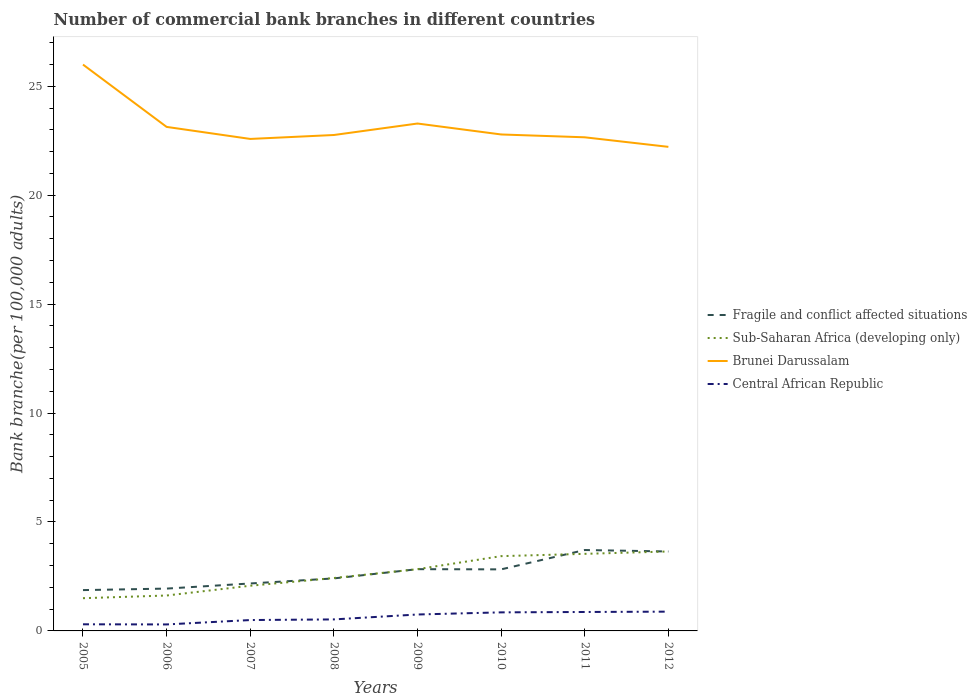How many different coloured lines are there?
Keep it short and to the point. 4. Across all years, what is the maximum number of commercial bank branches in Fragile and conflict affected situations?
Provide a succinct answer. 1.87. In which year was the number of commercial bank branches in Fragile and conflict affected situations maximum?
Provide a succinct answer. 2005. What is the total number of commercial bank branches in Brunei Darussalam in the graph?
Make the answer very short. 0.55. What is the difference between the highest and the second highest number of commercial bank branches in Sub-Saharan Africa (developing only)?
Offer a terse response. 2.14. What is the difference between the highest and the lowest number of commercial bank branches in Sub-Saharan Africa (developing only)?
Make the answer very short. 4. Is the number of commercial bank branches in Fragile and conflict affected situations strictly greater than the number of commercial bank branches in Brunei Darussalam over the years?
Ensure brevity in your answer.  Yes. How many lines are there?
Offer a very short reply. 4. What is the difference between two consecutive major ticks on the Y-axis?
Make the answer very short. 5. Does the graph contain grids?
Your answer should be very brief. No. How many legend labels are there?
Keep it short and to the point. 4. What is the title of the graph?
Keep it short and to the point. Number of commercial bank branches in different countries. Does "India" appear as one of the legend labels in the graph?
Your answer should be compact. No. What is the label or title of the X-axis?
Offer a very short reply. Years. What is the label or title of the Y-axis?
Keep it short and to the point. Bank branche(per 100,0 adults). What is the Bank branche(per 100,000 adults) of Fragile and conflict affected situations in 2005?
Your answer should be very brief. 1.87. What is the Bank branche(per 100,000 adults) in Sub-Saharan Africa (developing only) in 2005?
Make the answer very short. 1.5. What is the Bank branche(per 100,000 adults) of Brunei Darussalam in 2005?
Your response must be concise. 25.99. What is the Bank branche(per 100,000 adults) of Central African Republic in 2005?
Your response must be concise. 0.3. What is the Bank branche(per 100,000 adults) in Fragile and conflict affected situations in 2006?
Offer a terse response. 1.94. What is the Bank branche(per 100,000 adults) of Sub-Saharan Africa (developing only) in 2006?
Give a very brief answer. 1.63. What is the Bank branche(per 100,000 adults) of Brunei Darussalam in 2006?
Offer a very short reply. 23.13. What is the Bank branche(per 100,000 adults) in Central African Republic in 2006?
Provide a short and direct response. 0.3. What is the Bank branche(per 100,000 adults) of Fragile and conflict affected situations in 2007?
Ensure brevity in your answer.  2.18. What is the Bank branche(per 100,000 adults) in Sub-Saharan Africa (developing only) in 2007?
Your answer should be very brief. 2.07. What is the Bank branche(per 100,000 adults) in Brunei Darussalam in 2007?
Your response must be concise. 22.58. What is the Bank branche(per 100,000 adults) in Central African Republic in 2007?
Make the answer very short. 0.5. What is the Bank branche(per 100,000 adults) in Fragile and conflict affected situations in 2008?
Provide a short and direct response. 2.41. What is the Bank branche(per 100,000 adults) in Sub-Saharan Africa (developing only) in 2008?
Keep it short and to the point. 2.43. What is the Bank branche(per 100,000 adults) of Brunei Darussalam in 2008?
Provide a short and direct response. 22.76. What is the Bank branche(per 100,000 adults) in Central African Republic in 2008?
Your answer should be very brief. 0.53. What is the Bank branche(per 100,000 adults) of Fragile and conflict affected situations in 2009?
Your answer should be very brief. 2.83. What is the Bank branche(per 100,000 adults) of Sub-Saharan Africa (developing only) in 2009?
Provide a succinct answer. 2.83. What is the Bank branche(per 100,000 adults) in Brunei Darussalam in 2009?
Make the answer very short. 23.29. What is the Bank branche(per 100,000 adults) in Central African Republic in 2009?
Give a very brief answer. 0.75. What is the Bank branche(per 100,000 adults) in Fragile and conflict affected situations in 2010?
Make the answer very short. 2.83. What is the Bank branche(per 100,000 adults) of Sub-Saharan Africa (developing only) in 2010?
Keep it short and to the point. 3.43. What is the Bank branche(per 100,000 adults) of Brunei Darussalam in 2010?
Offer a terse response. 22.79. What is the Bank branche(per 100,000 adults) of Central African Republic in 2010?
Ensure brevity in your answer.  0.85. What is the Bank branche(per 100,000 adults) in Fragile and conflict affected situations in 2011?
Ensure brevity in your answer.  3.71. What is the Bank branche(per 100,000 adults) in Sub-Saharan Africa (developing only) in 2011?
Offer a terse response. 3.54. What is the Bank branche(per 100,000 adults) of Brunei Darussalam in 2011?
Offer a very short reply. 22.66. What is the Bank branche(per 100,000 adults) of Central African Republic in 2011?
Offer a terse response. 0.87. What is the Bank branche(per 100,000 adults) of Fragile and conflict affected situations in 2012?
Provide a short and direct response. 3.65. What is the Bank branche(per 100,000 adults) in Sub-Saharan Africa (developing only) in 2012?
Your response must be concise. 3.65. What is the Bank branche(per 100,000 adults) in Brunei Darussalam in 2012?
Ensure brevity in your answer.  22.22. What is the Bank branche(per 100,000 adults) of Central African Republic in 2012?
Your answer should be very brief. 0.88. Across all years, what is the maximum Bank branche(per 100,000 adults) of Fragile and conflict affected situations?
Offer a terse response. 3.71. Across all years, what is the maximum Bank branche(per 100,000 adults) of Sub-Saharan Africa (developing only)?
Ensure brevity in your answer.  3.65. Across all years, what is the maximum Bank branche(per 100,000 adults) of Brunei Darussalam?
Make the answer very short. 25.99. Across all years, what is the maximum Bank branche(per 100,000 adults) in Central African Republic?
Provide a short and direct response. 0.88. Across all years, what is the minimum Bank branche(per 100,000 adults) of Fragile and conflict affected situations?
Offer a very short reply. 1.87. Across all years, what is the minimum Bank branche(per 100,000 adults) in Sub-Saharan Africa (developing only)?
Your answer should be very brief. 1.5. Across all years, what is the minimum Bank branche(per 100,000 adults) in Brunei Darussalam?
Your answer should be compact. 22.22. Across all years, what is the minimum Bank branche(per 100,000 adults) in Central African Republic?
Your answer should be compact. 0.3. What is the total Bank branche(per 100,000 adults) in Fragile and conflict affected situations in the graph?
Ensure brevity in your answer.  21.42. What is the total Bank branche(per 100,000 adults) of Sub-Saharan Africa (developing only) in the graph?
Your answer should be very brief. 21.08. What is the total Bank branche(per 100,000 adults) of Brunei Darussalam in the graph?
Make the answer very short. 185.42. What is the total Bank branche(per 100,000 adults) of Central African Republic in the graph?
Your response must be concise. 4.99. What is the difference between the Bank branche(per 100,000 adults) of Fragile and conflict affected situations in 2005 and that in 2006?
Offer a very short reply. -0.07. What is the difference between the Bank branche(per 100,000 adults) of Sub-Saharan Africa (developing only) in 2005 and that in 2006?
Provide a succinct answer. -0.12. What is the difference between the Bank branche(per 100,000 adults) of Brunei Darussalam in 2005 and that in 2006?
Your answer should be very brief. 2.86. What is the difference between the Bank branche(per 100,000 adults) in Central African Republic in 2005 and that in 2006?
Provide a short and direct response. 0.01. What is the difference between the Bank branche(per 100,000 adults) in Fragile and conflict affected situations in 2005 and that in 2007?
Provide a succinct answer. -0.3. What is the difference between the Bank branche(per 100,000 adults) in Sub-Saharan Africa (developing only) in 2005 and that in 2007?
Ensure brevity in your answer.  -0.57. What is the difference between the Bank branche(per 100,000 adults) in Brunei Darussalam in 2005 and that in 2007?
Offer a very short reply. 3.41. What is the difference between the Bank branche(per 100,000 adults) of Central African Republic in 2005 and that in 2007?
Offer a terse response. -0.2. What is the difference between the Bank branche(per 100,000 adults) of Fragile and conflict affected situations in 2005 and that in 2008?
Provide a short and direct response. -0.54. What is the difference between the Bank branche(per 100,000 adults) of Sub-Saharan Africa (developing only) in 2005 and that in 2008?
Offer a terse response. -0.93. What is the difference between the Bank branche(per 100,000 adults) of Brunei Darussalam in 2005 and that in 2008?
Give a very brief answer. 3.23. What is the difference between the Bank branche(per 100,000 adults) of Central African Republic in 2005 and that in 2008?
Provide a succinct answer. -0.22. What is the difference between the Bank branche(per 100,000 adults) of Fragile and conflict affected situations in 2005 and that in 2009?
Make the answer very short. -0.96. What is the difference between the Bank branche(per 100,000 adults) of Sub-Saharan Africa (developing only) in 2005 and that in 2009?
Your answer should be very brief. -1.33. What is the difference between the Bank branche(per 100,000 adults) in Brunei Darussalam in 2005 and that in 2009?
Provide a short and direct response. 2.71. What is the difference between the Bank branche(per 100,000 adults) in Central African Republic in 2005 and that in 2009?
Make the answer very short. -0.45. What is the difference between the Bank branche(per 100,000 adults) of Fragile and conflict affected situations in 2005 and that in 2010?
Ensure brevity in your answer.  -0.95. What is the difference between the Bank branche(per 100,000 adults) in Sub-Saharan Africa (developing only) in 2005 and that in 2010?
Give a very brief answer. -1.93. What is the difference between the Bank branche(per 100,000 adults) of Brunei Darussalam in 2005 and that in 2010?
Make the answer very short. 3.21. What is the difference between the Bank branche(per 100,000 adults) of Central African Republic in 2005 and that in 2010?
Keep it short and to the point. -0.55. What is the difference between the Bank branche(per 100,000 adults) of Fragile and conflict affected situations in 2005 and that in 2011?
Your answer should be compact. -1.84. What is the difference between the Bank branche(per 100,000 adults) of Sub-Saharan Africa (developing only) in 2005 and that in 2011?
Make the answer very short. -2.04. What is the difference between the Bank branche(per 100,000 adults) in Brunei Darussalam in 2005 and that in 2011?
Give a very brief answer. 3.34. What is the difference between the Bank branche(per 100,000 adults) of Central African Republic in 2005 and that in 2011?
Offer a terse response. -0.57. What is the difference between the Bank branche(per 100,000 adults) in Fragile and conflict affected situations in 2005 and that in 2012?
Your response must be concise. -1.77. What is the difference between the Bank branche(per 100,000 adults) in Sub-Saharan Africa (developing only) in 2005 and that in 2012?
Keep it short and to the point. -2.14. What is the difference between the Bank branche(per 100,000 adults) in Brunei Darussalam in 2005 and that in 2012?
Ensure brevity in your answer.  3.78. What is the difference between the Bank branche(per 100,000 adults) of Central African Republic in 2005 and that in 2012?
Your response must be concise. -0.58. What is the difference between the Bank branche(per 100,000 adults) in Fragile and conflict affected situations in 2006 and that in 2007?
Provide a short and direct response. -0.23. What is the difference between the Bank branche(per 100,000 adults) in Sub-Saharan Africa (developing only) in 2006 and that in 2007?
Offer a very short reply. -0.45. What is the difference between the Bank branche(per 100,000 adults) in Brunei Darussalam in 2006 and that in 2007?
Keep it short and to the point. 0.55. What is the difference between the Bank branche(per 100,000 adults) in Central African Republic in 2006 and that in 2007?
Offer a very short reply. -0.2. What is the difference between the Bank branche(per 100,000 adults) in Fragile and conflict affected situations in 2006 and that in 2008?
Provide a succinct answer. -0.47. What is the difference between the Bank branche(per 100,000 adults) in Sub-Saharan Africa (developing only) in 2006 and that in 2008?
Keep it short and to the point. -0.8. What is the difference between the Bank branche(per 100,000 adults) of Brunei Darussalam in 2006 and that in 2008?
Ensure brevity in your answer.  0.37. What is the difference between the Bank branche(per 100,000 adults) of Central African Republic in 2006 and that in 2008?
Offer a terse response. -0.23. What is the difference between the Bank branche(per 100,000 adults) in Fragile and conflict affected situations in 2006 and that in 2009?
Provide a succinct answer. -0.89. What is the difference between the Bank branche(per 100,000 adults) of Sub-Saharan Africa (developing only) in 2006 and that in 2009?
Keep it short and to the point. -1.21. What is the difference between the Bank branche(per 100,000 adults) of Brunei Darussalam in 2006 and that in 2009?
Provide a succinct answer. -0.15. What is the difference between the Bank branche(per 100,000 adults) in Central African Republic in 2006 and that in 2009?
Give a very brief answer. -0.46. What is the difference between the Bank branche(per 100,000 adults) in Fragile and conflict affected situations in 2006 and that in 2010?
Ensure brevity in your answer.  -0.88. What is the difference between the Bank branche(per 100,000 adults) in Sub-Saharan Africa (developing only) in 2006 and that in 2010?
Make the answer very short. -1.81. What is the difference between the Bank branche(per 100,000 adults) in Brunei Darussalam in 2006 and that in 2010?
Provide a succinct answer. 0.35. What is the difference between the Bank branche(per 100,000 adults) of Central African Republic in 2006 and that in 2010?
Your answer should be very brief. -0.55. What is the difference between the Bank branche(per 100,000 adults) of Fragile and conflict affected situations in 2006 and that in 2011?
Provide a short and direct response. -1.77. What is the difference between the Bank branche(per 100,000 adults) in Sub-Saharan Africa (developing only) in 2006 and that in 2011?
Give a very brief answer. -1.91. What is the difference between the Bank branche(per 100,000 adults) of Brunei Darussalam in 2006 and that in 2011?
Provide a succinct answer. 0.48. What is the difference between the Bank branche(per 100,000 adults) of Central African Republic in 2006 and that in 2011?
Ensure brevity in your answer.  -0.57. What is the difference between the Bank branche(per 100,000 adults) of Fragile and conflict affected situations in 2006 and that in 2012?
Provide a succinct answer. -1.7. What is the difference between the Bank branche(per 100,000 adults) of Sub-Saharan Africa (developing only) in 2006 and that in 2012?
Your answer should be very brief. -2.02. What is the difference between the Bank branche(per 100,000 adults) of Brunei Darussalam in 2006 and that in 2012?
Your response must be concise. 0.92. What is the difference between the Bank branche(per 100,000 adults) of Central African Republic in 2006 and that in 2012?
Give a very brief answer. -0.59. What is the difference between the Bank branche(per 100,000 adults) of Fragile and conflict affected situations in 2007 and that in 2008?
Keep it short and to the point. -0.23. What is the difference between the Bank branche(per 100,000 adults) of Sub-Saharan Africa (developing only) in 2007 and that in 2008?
Offer a very short reply. -0.35. What is the difference between the Bank branche(per 100,000 adults) of Brunei Darussalam in 2007 and that in 2008?
Your answer should be compact. -0.18. What is the difference between the Bank branche(per 100,000 adults) of Central African Republic in 2007 and that in 2008?
Keep it short and to the point. -0.03. What is the difference between the Bank branche(per 100,000 adults) in Fragile and conflict affected situations in 2007 and that in 2009?
Provide a short and direct response. -0.66. What is the difference between the Bank branche(per 100,000 adults) in Sub-Saharan Africa (developing only) in 2007 and that in 2009?
Provide a short and direct response. -0.76. What is the difference between the Bank branche(per 100,000 adults) in Brunei Darussalam in 2007 and that in 2009?
Give a very brief answer. -0.71. What is the difference between the Bank branche(per 100,000 adults) of Central African Republic in 2007 and that in 2009?
Offer a very short reply. -0.25. What is the difference between the Bank branche(per 100,000 adults) of Fragile and conflict affected situations in 2007 and that in 2010?
Provide a short and direct response. -0.65. What is the difference between the Bank branche(per 100,000 adults) in Sub-Saharan Africa (developing only) in 2007 and that in 2010?
Your answer should be compact. -1.36. What is the difference between the Bank branche(per 100,000 adults) of Brunei Darussalam in 2007 and that in 2010?
Give a very brief answer. -0.2. What is the difference between the Bank branche(per 100,000 adults) in Central African Republic in 2007 and that in 2010?
Your answer should be compact. -0.35. What is the difference between the Bank branche(per 100,000 adults) in Fragile and conflict affected situations in 2007 and that in 2011?
Offer a very short reply. -1.54. What is the difference between the Bank branche(per 100,000 adults) in Sub-Saharan Africa (developing only) in 2007 and that in 2011?
Give a very brief answer. -1.46. What is the difference between the Bank branche(per 100,000 adults) in Brunei Darussalam in 2007 and that in 2011?
Provide a succinct answer. -0.07. What is the difference between the Bank branche(per 100,000 adults) in Central African Republic in 2007 and that in 2011?
Keep it short and to the point. -0.37. What is the difference between the Bank branche(per 100,000 adults) in Fragile and conflict affected situations in 2007 and that in 2012?
Make the answer very short. -1.47. What is the difference between the Bank branche(per 100,000 adults) of Sub-Saharan Africa (developing only) in 2007 and that in 2012?
Your answer should be compact. -1.57. What is the difference between the Bank branche(per 100,000 adults) of Brunei Darussalam in 2007 and that in 2012?
Your answer should be very brief. 0.36. What is the difference between the Bank branche(per 100,000 adults) in Central African Republic in 2007 and that in 2012?
Ensure brevity in your answer.  -0.39. What is the difference between the Bank branche(per 100,000 adults) in Fragile and conflict affected situations in 2008 and that in 2009?
Give a very brief answer. -0.42. What is the difference between the Bank branche(per 100,000 adults) of Sub-Saharan Africa (developing only) in 2008 and that in 2009?
Offer a terse response. -0.41. What is the difference between the Bank branche(per 100,000 adults) in Brunei Darussalam in 2008 and that in 2009?
Offer a terse response. -0.53. What is the difference between the Bank branche(per 100,000 adults) in Central African Republic in 2008 and that in 2009?
Make the answer very short. -0.23. What is the difference between the Bank branche(per 100,000 adults) of Fragile and conflict affected situations in 2008 and that in 2010?
Provide a short and direct response. -0.41. What is the difference between the Bank branche(per 100,000 adults) of Sub-Saharan Africa (developing only) in 2008 and that in 2010?
Ensure brevity in your answer.  -1. What is the difference between the Bank branche(per 100,000 adults) in Brunei Darussalam in 2008 and that in 2010?
Ensure brevity in your answer.  -0.02. What is the difference between the Bank branche(per 100,000 adults) of Central African Republic in 2008 and that in 2010?
Your answer should be compact. -0.32. What is the difference between the Bank branche(per 100,000 adults) in Fragile and conflict affected situations in 2008 and that in 2011?
Offer a terse response. -1.3. What is the difference between the Bank branche(per 100,000 adults) of Sub-Saharan Africa (developing only) in 2008 and that in 2011?
Keep it short and to the point. -1.11. What is the difference between the Bank branche(per 100,000 adults) in Brunei Darussalam in 2008 and that in 2011?
Give a very brief answer. 0.11. What is the difference between the Bank branche(per 100,000 adults) of Central African Republic in 2008 and that in 2011?
Offer a very short reply. -0.34. What is the difference between the Bank branche(per 100,000 adults) of Fragile and conflict affected situations in 2008 and that in 2012?
Provide a short and direct response. -1.24. What is the difference between the Bank branche(per 100,000 adults) of Sub-Saharan Africa (developing only) in 2008 and that in 2012?
Your answer should be compact. -1.22. What is the difference between the Bank branche(per 100,000 adults) of Brunei Darussalam in 2008 and that in 2012?
Keep it short and to the point. 0.54. What is the difference between the Bank branche(per 100,000 adults) in Central African Republic in 2008 and that in 2012?
Your answer should be compact. -0.36. What is the difference between the Bank branche(per 100,000 adults) in Fragile and conflict affected situations in 2009 and that in 2010?
Your response must be concise. 0.01. What is the difference between the Bank branche(per 100,000 adults) of Sub-Saharan Africa (developing only) in 2009 and that in 2010?
Offer a very short reply. -0.6. What is the difference between the Bank branche(per 100,000 adults) in Brunei Darussalam in 2009 and that in 2010?
Make the answer very short. 0.5. What is the difference between the Bank branche(per 100,000 adults) of Central African Republic in 2009 and that in 2010?
Make the answer very short. -0.1. What is the difference between the Bank branche(per 100,000 adults) of Fragile and conflict affected situations in 2009 and that in 2011?
Your response must be concise. -0.88. What is the difference between the Bank branche(per 100,000 adults) in Sub-Saharan Africa (developing only) in 2009 and that in 2011?
Your response must be concise. -0.7. What is the difference between the Bank branche(per 100,000 adults) in Brunei Darussalam in 2009 and that in 2011?
Your response must be concise. 0.63. What is the difference between the Bank branche(per 100,000 adults) in Central African Republic in 2009 and that in 2011?
Provide a succinct answer. -0.12. What is the difference between the Bank branche(per 100,000 adults) of Fragile and conflict affected situations in 2009 and that in 2012?
Make the answer very short. -0.81. What is the difference between the Bank branche(per 100,000 adults) in Sub-Saharan Africa (developing only) in 2009 and that in 2012?
Your response must be concise. -0.81. What is the difference between the Bank branche(per 100,000 adults) in Brunei Darussalam in 2009 and that in 2012?
Give a very brief answer. 1.07. What is the difference between the Bank branche(per 100,000 adults) in Central African Republic in 2009 and that in 2012?
Your answer should be very brief. -0.13. What is the difference between the Bank branche(per 100,000 adults) in Fragile and conflict affected situations in 2010 and that in 2011?
Give a very brief answer. -0.89. What is the difference between the Bank branche(per 100,000 adults) of Sub-Saharan Africa (developing only) in 2010 and that in 2011?
Provide a short and direct response. -0.11. What is the difference between the Bank branche(per 100,000 adults) of Brunei Darussalam in 2010 and that in 2011?
Your answer should be compact. 0.13. What is the difference between the Bank branche(per 100,000 adults) in Central African Republic in 2010 and that in 2011?
Offer a terse response. -0.02. What is the difference between the Bank branche(per 100,000 adults) in Fragile and conflict affected situations in 2010 and that in 2012?
Offer a very short reply. -0.82. What is the difference between the Bank branche(per 100,000 adults) in Sub-Saharan Africa (developing only) in 2010 and that in 2012?
Keep it short and to the point. -0.21. What is the difference between the Bank branche(per 100,000 adults) in Brunei Darussalam in 2010 and that in 2012?
Your response must be concise. 0.57. What is the difference between the Bank branche(per 100,000 adults) of Central African Republic in 2010 and that in 2012?
Ensure brevity in your answer.  -0.03. What is the difference between the Bank branche(per 100,000 adults) in Fragile and conflict affected situations in 2011 and that in 2012?
Offer a very short reply. 0.07. What is the difference between the Bank branche(per 100,000 adults) in Sub-Saharan Africa (developing only) in 2011 and that in 2012?
Keep it short and to the point. -0.11. What is the difference between the Bank branche(per 100,000 adults) in Brunei Darussalam in 2011 and that in 2012?
Provide a short and direct response. 0.44. What is the difference between the Bank branche(per 100,000 adults) in Central African Republic in 2011 and that in 2012?
Provide a succinct answer. -0.02. What is the difference between the Bank branche(per 100,000 adults) in Fragile and conflict affected situations in 2005 and the Bank branche(per 100,000 adults) in Sub-Saharan Africa (developing only) in 2006?
Offer a terse response. 0.25. What is the difference between the Bank branche(per 100,000 adults) of Fragile and conflict affected situations in 2005 and the Bank branche(per 100,000 adults) of Brunei Darussalam in 2006?
Offer a very short reply. -21.26. What is the difference between the Bank branche(per 100,000 adults) of Fragile and conflict affected situations in 2005 and the Bank branche(per 100,000 adults) of Central African Republic in 2006?
Offer a very short reply. 1.58. What is the difference between the Bank branche(per 100,000 adults) of Sub-Saharan Africa (developing only) in 2005 and the Bank branche(per 100,000 adults) of Brunei Darussalam in 2006?
Ensure brevity in your answer.  -21.63. What is the difference between the Bank branche(per 100,000 adults) in Sub-Saharan Africa (developing only) in 2005 and the Bank branche(per 100,000 adults) in Central African Republic in 2006?
Keep it short and to the point. 1.2. What is the difference between the Bank branche(per 100,000 adults) in Brunei Darussalam in 2005 and the Bank branche(per 100,000 adults) in Central African Republic in 2006?
Your answer should be compact. 25.7. What is the difference between the Bank branche(per 100,000 adults) of Fragile and conflict affected situations in 2005 and the Bank branche(per 100,000 adults) of Sub-Saharan Africa (developing only) in 2007?
Provide a succinct answer. -0.2. What is the difference between the Bank branche(per 100,000 adults) in Fragile and conflict affected situations in 2005 and the Bank branche(per 100,000 adults) in Brunei Darussalam in 2007?
Give a very brief answer. -20.71. What is the difference between the Bank branche(per 100,000 adults) in Fragile and conflict affected situations in 2005 and the Bank branche(per 100,000 adults) in Central African Republic in 2007?
Make the answer very short. 1.37. What is the difference between the Bank branche(per 100,000 adults) of Sub-Saharan Africa (developing only) in 2005 and the Bank branche(per 100,000 adults) of Brunei Darussalam in 2007?
Provide a succinct answer. -21.08. What is the difference between the Bank branche(per 100,000 adults) in Sub-Saharan Africa (developing only) in 2005 and the Bank branche(per 100,000 adults) in Central African Republic in 2007?
Your response must be concise. 1. What is the difference between the Bank branche(per 100,000 adults) in Brunei Darussalam in 2005 and the Bank branche(per 100,000 adults) in Central African Republic in 2007?
Offer a terse response. 25.49. What is the difference between the Bank branche(per 100,000 adults) in Fragile and conflict affected situations in 2005 and the Bank branche(per 100,000 adults) in Sub-Saharan Africa (developing only) in 2008?
Your answer should be compact. -0.55. What is the difference between the Bank branche(per 100,000 adults) in Fragile and conflict affected situations in 2005 and the Bank branche(per 100,000 adults) in Brunei Darussalam in 2008?
Give a very brief answer. -20.89. What is the difference between the Bank branche(per 100,000 adults) of Fragile and conflict affected situations in 2005 and the Bank branche(per 100,000 adults) of Central African Republic in 2008?
Offer a very short reply. 1.35. What is the difference between the Bank branche(per 100,000 adults) of Sub-Saharan Africa (developing only) in 2005 and the Bank branche(per 100,000 adults) of Brunei Darussalam in 2008?
Offer a very short reply. -21.26. What is the difference between the Bank branche(per 100,000 adults) in Sub-Saharan Africa (developing only) in 2005 and the Bank branche(per 100,000 adults) in Central African Republic in 2008?
Your answer should be very brief. 0.97. What is the difference between the Bank branche(per 100,000 adults) of Brunei Darussalam in 2005 and the Bank branche(per 100,000 adults) of Central African Republic in 2008?
Ensure brevity in your answer.  25.47. What is the difference between the Bank branche(per 100,000 adults) of Fragile and conflict affected situations in 2005 and the Bank branche(per 100,000 adults) of Sub-Saharan Africa (developing only) in 2009?
Your answer should be very brief. -0.96. What is the difference between the Bank branche(per 100,000 adults) of Fragile and conflict affected situations in 2005 and the Bank branche(per 100,000 adults) of Brunei Darussalam in 2009?
Make the answer very short. -21.41. What is the difference between the Bank branche(per 100,000 adults) of Fragile and conflict affected situations in 2005 and the Bank branche(per 100,000 adults) of Central African Republic in 2009?
Provide a short and direct response. 1.12. What is the difference between the Bank branche(per 100,000 adults) in Sub-Saharan Africa (developing only) in 2005 and the Bank branche(per 100,000 adults) in Brunei Darussalam in 2009?
Make the answer very short. -21.79. What is the difference between the Bank branche(per 100,000 adults) of Sub-Saharan Africa (developing only) in 2005 and the Bank branche(per 100,000 adults) of Central African Republic in 2009?
Offer a very short reply. 0.75. What is the difference between the Bank branche(per 100,000 adults) in Brunei Darussalam in 2005 and the Bank branche(per 100,000 adults) in Central African Republic in 2009?
Provide a short and direct response. 25.24. What is the difference between the Bank branche(per 100,000 adults) in Fragile and conflict affected situations in 2005 and the Bank branche(per 100,000 adults) in Sub-Saharan Africa (developing only) in 2010?
Give a very brief answer. -1.56. What is the difference between the Bank branche(per 100,000 adults) of Fragile and conflict affected situations in 2005 and the Bank branche(per 100,000 adults) of Brunei Darussalam in 2010?
Offer a terse response. -20.91. What is the difference between the Bank branche(per 100,000 adults) in Fragile and conflict affected situations in 2005 and the Bank branche(per 100,000 adults) in Central African Republic in 2010?
Provide a succinct answer. 1.02. What is the difference between the Bank branche(per 100,000 adults) in Sub-Saharan Africa (developing only) in 2005 and the Bank branche(per 100,000 adults) in Brunei Darussalam in 2010?
Provide a succinct answer. -21.28. What is the difference between the Bank branche(per 100,000 adults) of Sub-Saharan Africa (developing only) in 2005 and the Bank branche(per 100,000 adults) of Central African Republic in 2010?
Give a very brief answer. 0.65. What is the difference between the Bank branche(per 100,000 adults) in Brunei Darussalam in 2005 and the Bank branche(per 100,000 adults) in Central African Republic in 2010?
Provide a succinct answer. 25.14. What is the difference between the Bank branche(per 100,000 adults) of Fragile and conflict affected situations in 2005 and the Bank branche(per 100,000 adults) of Sub-Saharan Africa (developing only) in 2011?
Your response must be concise. -1.66. What is the difference between the Bank branche(per 100,000 adults) of Fragile and conflict affected situations in 2005 and the Bank branche(per 100,000 adults) of Brunei Darussalam in 2011?
Your response must be concise. -20.78. What is the difference between the Bank branche(per 100,000 adults) of Sub-Saharan Africa (developing only) in 2005 and the Bank branche(per 100,000 adults) of Brunei Darussalam in 2011?
Give a very brief answer. -21.15. What is the difference between the Bank branche(per 100,000 adults) in Sub-Saharan Africa (developing only) in 2005 and the Bank branche(per 100,000 adults) in Central African Republic in 2011?
Make the answer very short. 0.63. What is the difference between the Bank branche(per 100,000 adults) of Brunei Darussalam in 2005 and the Bank branche(per 100,000 adults) of Central African Republic in 2011?
Ensure brevity in your answer.  25.12. What is the difference between the Bank branche(per 100,000 adults) of Fragile and conflict affected situations in 2005 and the Bank branche(per 100,000 adults) of Sub-Saharan Africa (developing only) in 2012?
Ensure brevity in your answer.  -1.77. What is the difference between the Bank branche(per 100,000 adults) of Fragile and conflict affected situations in 2005 and the Bank branche(per 100,000 adults) of Brunei Darussalam in 2012?
Your answer should be very brief. -20.34. What is the difference between the Bank branche(per 100,000 adults) in Fragile and conflict affected situations in 2005 and the Bank branche(per 100,000 adults) in Central African Republic in 2012?
Give a very brief answer. 0.99. What is the difference between the Bank branche(per 100,000 adults) of Sub-Saharan Africa (developing only) in 2005 and the Bank branche(per 100,000 adults) of Brunei Darussalam in 2012?
Ensure brevity in your answer.  -20.72. What is the difference between the Bank branche(per 100,000 adults) in Sub-Saharan Africa (developing only) in 2005 and the Bank branche(per 100,000 adults) in Central African Republic in 2012?
Provide a succinct answer. 0.62. What is the difference between the Bank branche(per 100,000 adults) of Brunei Darussalam in 2005 and the Bank branche(per 100,000 adults) of Central African Republic in 2012?
Offer a terse response. 25.11. What is the difference between the Bank branche(per 100,000 adults) of Fragile and conflict affected situations in 2006 and the Bank branche(per 100,000 adults) of Sub-Saharan Africa (developing only) in 2007?
Keep it short and to the point. -0.13. What is the difference between the Bank branche(per 100,000 adults) in Fragile and conflict affected situations in 2006 and the Bank branche(per 100,000 adults) in Brunei Darussalam in 2007?
Your response must be concise. -20.64. What is the difference between the Bank branche(per 100,000 adults) in Fragile and conflict affected situations in 2006 and the Bank branche(per 100,000 adults) in Central African Republic in 2007?
Make the answer very short. 1.44. What is the difference between the Bank branche(per 100,000 adults) of Sub-Saharan Africa (developing only) in 2006 and the Bank branche(per 100,000 adults) of Brunei Darussalam in 2007?
Provide a short and direct response. -20.96. What is the difference between the Bank branche(per 100,000 adults) of Sub-Saharan Africa (developing only) in 2006 and the Bank branche(per 100,000 adults) of Central African Republic in 2007?
Provide a succinct answer. 1.13. What is the difference between the Bank branche(per 100,000 adults) in Brunei Darussalam in 2006 and the Bank branche(per 100,000 adults) in Central African Republic in 2007?
Provide a short and direct response. 22.63. What is the difference between the Bank branche(per 100,000 adults) in Fragile and conflict affected situations in 2006 and the Bank branche(per 100,000 adults) in Sub-Saharan Africa (developing only) in 2008?
Make the answer very short. -0.49. What is the difference between the Bank branche(per 100,000 adults) in Fragile and conflict affected situations in 2006 and the Bank branche(per 100,000 adults) in Brunei Darussalam in 2008?
Your answer should be compact. -20.82. What is the difference between the Bank branche(per 100,000 adults) in Fragile and conflict affected situations in 2006 and the Bank branche(per 100,000 adults) in Central African Republic in 2008?
Ensure brevity in your answer.  1.41. What is the difference between the Bank branche(per 100,000 adults) of Sub-Saharan Africa (developing only) in 2006 and the Bank branche(per 100,000 adults) of Brunei Darussalam in 2008?
Make the answer very short. -21.14. What is the difference between the Bank branche(per 100,000 adults) of Sub-Saharan Africa (developing only) in 2006 and the Bank branche(per 100,000 adults) of Central African Republic in 2008?
Keep it short and to the point. 1.1. What is the difference between the Bank branche(per 100,000 adults) in Brunei Darussalam in 2006 and the Bank branche(per 100,000 adults) in Central African Republic in 2008?
Offer a very short reply. 22.6. What is the difference between the Bank branche(per 100,000 adults) of Fragile and conflict affected situations in 2006 and the Bank branche(per 100,000 adults) of Sub-Saharan Africa (developing only) in 2009?
Provide a succinct answer. -0.89. What is the difference between the Bank branche(per 100,000 adults) of Fragile and conflict affected situations in 2006 and the Bank branche(per 100,000 adults) of Brunei Darussalam in 2009?
Your answer should be compact. -21.34. What is the difference between the Bank branche(per 100,000 adults) in Fragile and conflict affected situations in 2006 and the Bank branche(per 100,000 adults) in Central African Republic in 2009?
Ensure brevity in your answer.  1.19. What is the difference between the Bank branche(per 100,000 adults) of Sub-Saharan Africa (developing only) in 2006 and the Bank branche(per 100,000 adults) of Brunei Darussalam in 2009?
Keep it short and to the point. -21.66. What is the difference between the Bank branche(per 100,000 adults) of Sub-Saharan Africa (developing only) in 2006 and the Bank branche(per 100,000 adults) of Central African Republic in 2009?
Provide a short and direct response. 0.87. What is the difference between the Bank branche(per 100,000 adults) in Brunei Darussalam in 2006 and the Bank branche(per 100,000 adults) in Central African Republic in 2009?
Your answer should be compact. 22.38. What is the difference between the Bank branche(per 100,000 adults) of Fragile and conflict affected situations in 2006 and the Bank branche(per 100,000 adults) of Sub-Saharan Africa (developing only) in 2010?
Your answer should be very brief. -1.49. What is the difference between the Bank branche(per 100,000 adults) in Fragile and conflict affected situations in 2006 and the Bank branche(per 100,000 adults) in Brunei Darussalam in 2010?
Your answer should be compact. -20.84. What is the difference between the Bank branche(per 100,000 adults) in Fragile and conflict affected situations in 2006 and the Bank branche(per 100,000 adults) in Central African Republic in 2010?
Offer a terse response. 1.09. What is the difference between the Bank branche(per 100,000 adults) of Sub-Saharan Africa (developing only) in 2006 and the Bank branche(per 100,000 adults) of Brunei Darussalam in 2010?
Offer a terse response. -21.16. What is the difference between the Bank branche(per 100,000 adults) of Sub-Saharan Africa (developing only) in 2006 and the Bank branche(per 100,000 adults) of Central African Republic in 2010?
Your answer should be compact. 0.77. What is the difference between the Bank branche(per 100,000 adults) of Brunei Darussalam in 2006 and the Bank branche(per 100,000 adults) of Central African Republic in 2010?
Your answer should be very brief. 22.28. What is the difference between the Bank branche(per 100,000 adults) of Fragile and conflict affected situations in 2006 and the Bank branche(per 100,000 adults) of Sub-Saharan Africa (developing only) in 2011?
Make the answer very short. -1.59. What is the difference between the Bank branche(per 100,000 adults) of Fragile and conflict affected situations in 2006 and the Bank branche(per 100,000 adults) of Brunei Darussalam in 2011?
Offer a terse response. -20.71. What is the difference between the Bank branche(per 100,000 adults) of Fragile and conflict affected situations in 2006 and the Bank branche(per 100,000 adults) of Central African Republic in 2011?
Your response must be concise. 1.07. What is the difference between the Bank branche(per 100,000 adults) in Sub-Saharan Africa (developing only) in 2006 and the Bank branche(per 100,000 adults) in Brunei Darussalam in 2011?
Make the answer very short. -21.03. What is the difference between the Bank branche(per 100,000 adults) in Sub-Saharan Africa (developing only) in 2006 and the Bank branche(per 100,000 adults) in Central African Republic in 2011?
Your answer should be compact. 0.76. What is the difference between the Bank branche(per 100,000 adults) in Brunei Darussalam in 2006 and the Bank branche(per 100,000 adults) in Central African Republic in 2011?
Provide a short and direct response. 22.26. What is the difference between the Bank branche(per 100,000 adults) in Fragile and conflict affected situations in 2006 and the Bank branche(per 100,000 adults) in Sub-Saharan Africa (developing only) in 2012?
Make the answer very short. -1.7. What is the difference between the Bank branche(per 100,000 adults) in Fragile and conflict affected situations in 2006 and the Bank branche(per 100,000 adults) in Brunei Darussalam in 2012?
Make the answer very short. -20.27. What is the difference between the Bank branche(per 100,000 adults) in Fragile and conflict affected situations in 2006 and the Bank branche(per 100,000 adults) in Central African Republic in 2012?
Keep it short and to the point. 1.06. What is the difference between the Bank branche(per 100,000 adults) in Sub-Saharan Africa (developing only) in 2006 and the Bank branche(per 100,000 adults) in Brunei Darussalam in 2012?
Your answer should be very brief. -20.59. What is the difference between the Bank branche(per 100,000 adults) of Sub-Saharan Africa (developing only) in 2006 and the Bank branche(per 100,000 adults) of Central African Republic in 2012?
Your answer should be very brief. 0.74. What is the difference between the Bank branche(per 100,000 adults) in Brunei Darussalam in 2006 and the Bank branche(per 100,000 adults) in Central African Republic in 2012?
Provide a succinct answer. 22.25. What is the difference between the Bank branche(per 100,000 adults) of Fragile and conflict affected situations in 2007 and the Bank branche(per 100,000 adults) of Sub-Saharan Africa (developing only) in 2008?
Keep it short and to the point. -0.25. What is the difference between the Bank branche(per 100,000 adults) in Fragile and conflict affected situations in 2007 and the Bank branche(per 100,000 adults) in Brunei Darussalam in 2008?
Make the answer very short. -20.58. What is the difference between the Bank branche(per 100,000 adults) of Fragile and conflict affected situations in 2007 and the Bank branche(per 100,000 adults) of Central African Republic in 2008?
Your answer should be compact. 1.65. What is the difference between the Bank branche(per 100,000 adults) of Sub-Saharan Africa (developing only) in 2007 and the Bank branche(per 100,000 adults) of Brunei Darussalam in 2008?
Ensure brevity in your answer.  -20.69. What is the difference between the Bank branche(per 100,000 adults) in Sub-Saharan Africa (developing only) in 2007 and the Bank branche(per 100,000 adults) in Central African Republic in 2008?
Your response must be concise. 1.55. What is the difference between the Bank branche(per 100,000 adults) in Brunei Darussalam in 2007 and the Bank branche(per 100,000 adults) in Central African Republic in 2008?
Offer a terse response. 22.05. What is the difference between the Bank branche(per 100,000 adults) in Fragile and conflict affected situations in 2007 and the Bank branche(per 100,000 adults) in Sub-Saharan Africa (developing only) in 2009?
Keep it short and to the point. -0.66. What is the difference between the Bank branche(per 100,000 adults) in Fragile and conflict affected situations in 2007 and the Bank branche(per 100,000 adults) in Brunei Darussalam in 2009?
Keep it short and to the point. -21.11. What is the difference between the Bank branche(per 100,000 adults) in Fragile and conflict affected situations in 2007 and the Bank branche(per 100,000 adults) in Central African Republic in 2009?
Offer a terse response. 1.42. What is the difference between the Bank branche(per 100,000 adults) in Sub-Saharan Africa (developing only) in 2007 and the Bank branche(per 100,000 adults) in Brunei Darussalam in 2009?
Offer a terse response. -21.21. What is the difference between the Bank branche(per 100,000 adults) in Sub-Saharan Africa (developing only) in 2007 and the Bank branche(per 100,000 adults) in Central African Republic in 2009?
Your answer should be compact. 1.32. What is the difference between the Bank branche(per 100,000 adults) of Brunei Darussalam in 2007 and the Bank branche(per 100,000 adults) of Central African Republic in 2009?
Make the answer very short. 21.83. What is the difference between the Bank branche(per 100,000 adults) of Fragile and conflict affected situations in 2007 and the Bank branche(per 100,000 adults) of Sub-Saharan Africa (developing only) in 2010?
Your answer should be compact. -1.25. What is the difference between the Bank branche(per 100,000 adults) of Fragile and conflict affected situations in 2007 and the Bank branche(per 100,000 adults) of Brunei Darussalam in 2010?
Your answer should be compact. -20.61. What is the difference between the Bank branche(per 100,000 adults) of Fragile and conflict affected situations in 2007 and the Bank branche(per 100,000 adults) of Central African Republic in 2010?
Give a very brief answer. 1.33. What is the difference between the Bank branche(per 100,000 adults) in Sub-Saharan Africa (developing only) in 2007 and the Bank branche(per 100,000 adults) in Brunei Darussalam in 2010?
Give a very brief answer. -20.71. What is the difference between the Bank branche(per 100,000 adults) in Sub-Saharan Africa (developing only) in 2007 and the Bank branche(per 100,000 adults) in Central African Republic in 2010?
Provide a short and direct response. 1.22. What is the difference between the Bank branche(per 100,000 adults) of Brunei Darussalam in 2007 and the Bank branche(per 100,000 adults) of Central African Republic in 2010?
Your response must be concise. 21.73. What is the difference between the Bank branche(per 100,000 adults) in Fragile and conflict affected situations in 2007 and the Bank branche(per 100,000 adults) in Sub-Saharan Africa (developing only) in 2011?
Your answer should be very brief. -1.36. What is the difference between the Bank branche(per 100,000 adults) of Fragile and conflict affected situations in 2007 and the Bank branche(per 100,000 adults) of Brunei Darussalam in 2011?
Keep it short and to the point. -20.48. What is the difference between the Bank branche(per 100,000 adults) of Fragile and conflict affected situations in 2007 and the Bank branche(per 100,000 adults) of Central African Republic in 2011?
Provide a short and direct response. 1.31. What is the difference between the Bank branche(per 100,000 adults) of Sub-Saharan Africa (developing only) in 2007 and the Bank branche(per 100,000 adults) of Brunei Darussalam in 2011?
Make the answer very short. -20.58. What is the difference between the Bank branche(per 100,000 adults) in Sub-Saharan Africa (developing only) in 2007 and the Bank branche(per 100,000 adults) in Central African Republic in 2011?
Provide a short and direct response. 1.2. What is the difference between the Bank branche(per 100,000 adults) of Brunei Darussalam in 2007 and the Bank branche(per 100,000 adults) of Central African Republic in 2011?
Provide a short and direct response. 21.71. What is the difference between the Bank branche(per 100,000 adults) of Fragile and conflict affected situations in 2007 and the Bank branche(per 100,000 adults) of Sub-Saharan Africa (developing only) in 2012?
Your answer should be compact. -1.47. What is the difference between the Bank branche(per 100,000 adults) of Fragile and conflict affected situations in 2007 and the Bank branche(per 100,000 adults) of Brunei Darussalam in 2012?
Make the answer very short. -20.04. What is the difference between the Bank branche(per 100,000 adults) in Fragile and conflict affected situations in 2007 and the Bank branche(per 100,000 adults) in Central African Republic in 2012?
Offer a terse response. 1.29. What is the difference between the Bank branche(per 100,000 adults) of Sub-Saharan Africa (developing only) in 2007 and the Bank branche(per 100,000 adults) of Brunei Darussalam in 2012?
Ensure brevity in your answer.  -20.14. What is the difference between the Bank branche(per 100,000 adults) in Sub-Saharan Africa (developing only) in 2007 and the Bank branche(per 100,000 adults) in Central African Republic in 2012?
Provide a succinct answer. 1.19. What is the difference between the Bank branche(per 100,000 adults) in Brunei Darussalam in 2007 and the Bank branche(per 100,000 adults) in Central African Republic in 2012?
Offer a very short reply. 21.7. What is the difference between the Bank branche(per 100,000 adults) of Fragile and conflict affected situations in 2008 and the Bank branche(per 100,000 adults) of Sub-Saharan Africa (developing only) in 2009?
Give a very brief answer. -0.42. What is the difference between the Bank branche(per 100,000 adults) of Fragile and conflict affected situations in 2008 and the Bank branche(per 100,000 adults) of Brunei Darussalam in 2009?
Offer a terse response. -20.88. What is the difference between the Bank branche(per 100,000 adults) of Fragile and conflict affected situations in 2008 and the Bank branche(per 100,000 adults) of Central African Republic in 2009?
Provide a succinct answer. 1.66. What is the difference between the Bank branche(per 100,000 adults) in Sub-Saharan Africa (developing only) in 2008 and the Bank branche(per 100,000 adults) in Brunei Darussalam in 2009?
Offer a terse response. -20.86. What is the difference between the Bank branche(per 100,000 adults) of Sub-Saharan Africa (developing only) in 2008 and the Bank branche(per 100,000 adults) of Central African Republic in 2009?
Your answer should be compact. 1.67. What is the difference between the Bank branche(per 100,000 adults) of Brunei Darussalam in 2008 and the Bank branche(per 100,000 adults) of Central African Republic in 2009?
Your answer should be very brief. 22.01. What is the difference between the Bank branche(per 100,000 adults) of Fragile and conflict affected situations in 2008 and the Bank branche(per 100,000 adults) of Sub-Saharan Africa (developing only) in 2010?
Provide a succinct answer. -1.02. What is the difference between the Bank branche(per 100,000 adults) of Fragile and conflict affected situations in 2008 and the Bank branche(per 100,000 adults) of Brunei Darussalam in 2010?
Your answer should be very brief. -20.38. What is the difference between the Bank branche(per 100,000 adults) in Fragile and conflict affected situations in 2008 and the Bank branche(per 100,000 adults) in Central African Republic in 2010?
Provide a succinct answer. 1.56. What is the difference between the Bank branche(per 100,000 adults) of Sub-Saharan Africa (developing only) in 2008 and the Bank branche(per 100,000 adults) of Brunei Darussalam in 2010?
Provide a succinct answer. -20.36. What is the difference between the Bank branche(per 100,000 adults) in Sub-Saharan Africa (developing only) in 2008 and the Bank branche(per 100,000 adults) in Central African Republic in 2010?
Offer a terse response. 1.58. What is the difference between the Bank branche(per 100,000 adults) in Brunei Darussalam in 2008 and the Bank branche(per 100,000 adults) in Central African Republic in 2010?
Your response must be concise. 21.91. What is the difference between the Bank branche(per 100,000 adults) of Fragile and conflict affected situations in 2008 and the Bank branche(per 100,000 adults) of Sub-Saharan Africa (developing only) in 2011?
Make the answer very short. -1.13. What is the difference between the Bank branche(per 100,000 adults) of Fragile and conflict affected situations in 2008 and the Bank branche(per 100,000 adults) of Brunei Darussalam in 2011?
Your response must be concise. -20.25. What is the difference between the Bank branche(per 100,000 adults) of Fragile and conflict affected situations in 2008 and the Bank branche(per 100,000 adults) of Central African Republic in 2011?
Give a very brief answer. 1.54. What is the difference between the Bank branche(per 100,000 adults) in Sub-Saharan Africa (developing only) in 2008 and the Bank branche(per 100,000 adults) in Brunei Darussalam in 2011?
Provide a succinct answer. -20.23. What is the difference between the Bank branche(per 100,000 adults) of Sub-Saharan Africa (developing only) in 2008 and the Bank branche(per 100,000 adults) of Central African Republic in 2011?
Offer a terse response. 1.56. What is the difference between the Bank branche(per 100,000 adults) in Brunei Darussalam in 2008 and the Bank branche(per 100,000 adults) in Central African Republic in 2011?
Your response must be concise. 21.89. What is the difference between the Bank branche(per 100,000 adults) of Fragile and conflict affected situations in 2008 and the Bank branche(per 100,000 adults) of Sub-Saharan Africa (developing only) in 2012?
Provide a succinct answer. -1.24. What is the difference between the Bank branche(per 100,000 adults) of Fragile and conflict affected situations in 2008 and the Bank branche(per 100,000 adults) of Brunei Darussalam in 2012?
Offer a terse response. -19.81. What is the difference between the Bank branche(per 100,000 adults) of Fragile and conflict affected situations in 2008 and the Bank branche(per 100,000 adults) of Central African Republic in 2012?
Your answer should be very brief. 1.53. What is the difference between the Bank branche(per 100,000 adults) in Sub-Saharan Africa (developing only) in 2008 and the Bank branche(per 100,000 adults) in Brunei Darussalam in 2012?
Offer a very short reply. -19.79. What is the difference between the Bank branche(per 100,000 adults) in Sub-Saharan Africa (developing only) in 2008 and the Bank branche(per 100,000 adults) in Central African Republic in 2012?
Your response must be concise. 1.54. What is the difference between the Bank branche(per 100,000 adults) in Brunei Darussalam in 2008 and the Bank branche(per 100,000 adults) in Central African Republic in 2012?
Your answer should be very brief. 21.88. What is the difference between the Bank branche(per 100,000 adults) in Fragile and conflict affected situations in 2009 and the Bank branche(per 100,000 adults) in Sub-Saharan Africa (developing only) in 2010?
Offer a very short reply. -0.6. What is the difference between the Bank branche(per 100,000 adults) of Fragile and conflict affected situations in 2009 and the Bank branche(per 100,000 adults) of Brunei Darussalam in 2010?
Keep it short and to the point. -19.95. What is the difference between the Bank branche(per 100,000 adults) in Fragile and conflict affected situations in 2009 and the Bank branche(per 100,000 adults) in Central African Republic in 2010?
Offer a terse response. 1.98. What is the difference between the Bank branche(per 100,000 adults) of Sub-Saharan Africa (developing only) in 2009 and the Bank branche(per 100,000 adults) of Brunei Darussalam in 2010?
Keep it short and to the point. -19.95. What is the difference between the Bank branche(per 100,000 adults) of Sub-Saharan Africa (developing only) in 2009 and the Bank branche(per 100,000 adults) of Central African Republic in 2010?
Keep it short and to the point. 1.98. What is the difference between the Bank branche(per 100,000 adults) of Brunei Darussalam in 2009 and the Bank branche(per 100,000 adults) of Central African Republic in 2010?
Make the answer very short. 22.44. What is the difference between the Bank branche(per 100,000 adults) of Fragile and conflict affected situations in 2009 and the Bank branche(per 100,000 adults) of Sub-Saharan Africa (developing only) in 2011?
Provide a succinct answer. -0.7. What is the difference between the Bank branche(per 100,000 adults) of Fragile and conflict affected situations in 2009 and the Bank branche(per 100,000 adults) of Brunei Darussalam in 2011?
Make the answer very short. -19.82. What is the difference between the Bank branche(per 100,000 adults) of Fragile and conflict affected situations in 2009 and the Bank branche(per 100,000 adults) of Central African Republic in 2011?
Keep it short and to the point. 1.97. What is the difference between the Bank branche(per 100,000 adults) of Sub-Saharan Africa (developing only) in 2009 and the Bank branche(per 100,000 adults) of Brunei Darussalam in 2011?
Provide a short and direct response. -19.82. What is the difference between the Bank branche(per 100,000 adults) in Sub-Saharan Africa (developing only) in 2009 and the Bank branche(per 100,000 adults) in Central African Republic in 2011?
Your answer should be very brief. 1.97. What is the difference between the Bank branche(per 100,000 adults) of Brunei Darussalam in 2009 and the Bank branche(per 100,000 adults) of Central African Republic in 2011?
Ensure brevity in your answer.  22.42. What is the difference between the Bank branche(per 100,000 adults) of Fragile and conflict affected situations in 2009 and the Bank branche(per 100,000 adults) of Sub-Saharan Africa (developing only) in 2012?
Give a very brief answer. -0.81. What is the difference between the Bank branche(per 100,000 adults) in Fragile and conflict affected situations in 2009 and the Bank branche(per 100,000 adults) in Brunei Darussalam in 2012?
Provide a succinct answer. -19.38. What is the difference between the Bank branche(per 100,000 adults) in Fragile and conflict affected situations in 2009 and the Bank branche(per 100,000 adults) in Central African Republic in 2012?
Your answer should be very brief. 1.95. What is the difference between the Bank branche(per 100,000 adults) in Sub-Saharan Africa (developing only) in 2009 and the Bank branche(per 100,000 adults) in Brunei Darussalam in 2012?
Keep it short and to the point. -19.38. What is the difference between the Bank branche(per 100,000 adults) of Sub-Saharan Africa (developing only) in 2009 and the Bank branche(per 100,000 adults) of Central African Republic in 2012?
Make the answer very short. 1.95. What is the difference between the Bank branche(per 100,000 adults) of Brunei Darussalam in 2009 and the Bank branche(per 100,000 adults) of Central African Republic in 2012?
Make the answer very short. 22.4. What is the difference between the Bank branche(per 100,000 adults) in Fragile and conflict affected situations in 2010 and the Bank branche(per 100,000 adults) in Sub-Saharan Africa (developing only) in 2011?
Your answer should be compact. -0.71. What is the difference between the Bank branche(per 100,000 adults) of Fragile and conflict affected situations in 2010 and the Bank branche(per 100,000 adults) of Brunei Darussalam in 2011?
Keep it short and to the point. -19.83. What is the difference between the Bank branche(per 100,000 adults) of Fragile and conflict affected situations in 2010 and the Bank branche(per 100,000 adults) of Central African Republic in 2011?
Ensure brevity in your answer.  1.96. What is the difference between the Bank branche(per 100,000 adults) in Sub-Saharan Africa (developing only) in 2010 and the Bank branche(per 100,000 adults) in Brunei Darussalam in 2011?
Keep it short and to the point. -19.22. What is the difference between the Bank branche(per 100,000 adults) of Sub-Saharan Africa (developing only) in 2010 and the Bank branche(per 100,000 adults) of Central African Republic in 2011?
Ensure brevity in your answer.  2.56. What is the difference between the Bank branche(per 100,000 adults) in Brunei Darussalam in 2010 and the Bank branche(per 100,000 adults) in Central African Republic in 2011?
Your response must be concise. 21.92. What is the difference between the Bank branche(per 100,000 adults) of Fragile and conflict affected situations in 2010 and the Bank branche(per 100,000 adults) of Sub-Saharan Africa (developing only) in 2012?
Keep it short and to the point. -0.82. What is the difference between the Bank branche(per 100,000 adults) of Fragile and conflict affected situations in 2010 and the Bank branche(per 100,000 adults) of Brunei Darussalam in 2012?
Your answer should be compact. -19.39. What is the difference between the Bank branche(per 100,000 adults) of Fragile and conflict affected situations in 2010 and the Bank branche(per 100,000 adults) of Central African Republic in 2012?
Your response must be concise. 1.94. What is the difference between the Bank branche(per 100,000 adults) in Sub-Saharan Africa (developing only) in 2010 and the Bank branche(per 100,000 adults) in Brunei Darussalam in 2012?
Provide a succinct answer. -18.79. What is the difference between the Bank branche(per 100,000 adults) in Sub-Saharan Africa (developing only) in 2010 and the Bank branche(per 100,000 adults) in Central African Republic in 2012?
Offer a terse response. 2.55. What is the difference between the Bank branche(per 100,000 adults) in Brunei Darussalam in 2010 and the Bank branche(per 100,000 adults) in Central African Republic in 2012?
Ensure brevity in your answer.  21.9. What is the difference between the Bank branche(per 100,000 adults) in Fragile and conflict affected situations in 2011 and the Bank branche(per 100,000 adults) in Sub-Saharan Africa (developing only) in 2012?
Provide a short and direct response. 0.07. What is the difference between the Bank branche(per 100,000 adults) of Fragile and conflict affected situations in 2011 and the Bank branche(per 100,000 adults) of Brunei Darussalam in 2012?
Offer a very short reply. -18.5. What is the difference between the Bank branche(per 100,000 adults) of Fragile and conflict affected situations in 2011 and the Bank branche(per 100,000 adults) of Central African Republic in 2012?
Provide a short and direct response. 2.83. What is the difference between the Bank branche(per 100,000 adults) in Sub-Saharan Africa (developing only) in 2011 and the Bank branche(per 100,000 adults) in Brunei Darussalam in 2012?
Make the answer very short. -18.68. What is the difference between the Bank branche(per 100,000 adults) in Sub-Saharan Africa (developing only) in 2011 and the Bank branche(per 100,000 adults) in Central African Republic in 2012?
Your response must be concise. 2.65. What is the difference between the Bank branche(per 100,000 adults) of Brunei Darussalam in 2011 and the Bank branche(per 100,000 adults) of Central African Republic in 2012?
Keep it short and to the point. 21.77. What is the average Bank branche(per 100,000 adults) in Fragile and conflict affected situations per year?
Your answer should be very brief. 2.68. What is the average Bank branche(per 100,000 adults) in Sub-Saharan Africa (developing only) per year?
Provide a succinct answer. 2.63. What is the average Bank branche(per 100,000 adults) in Brunei Darussalam per year?
Provide a succinct answer. 23.18. What is the average Bank branche(per 100,000 adults) of Central African Republic per year?
Ensure brevity in your answer.  0.62. In the year 2005, what is the difference between the Bank branche(per 100,000 adults) in Fragile and conflict affected situations and Bank branche(per 100,000 adults) in Sub-Saharan Africa (developing only)?
Keep it short and to the point. 0.37. In the year 2005, what is the difference between the Bank branche(per 100,000 adults) of Fragile and conflict affected situations and Bank branche(per 100,000 adults) of Brunei Darussalam?
Your response must be concise. -24.12. In the year 2005, what is the difference between the Bank branche(per 100,000 adults) of Fragile and conflict affected situations and Bank branche(per 100,000 adults) of Central African Republic?
Your answer should be very brief. 1.57. In the year 2005, what is the difference between the Bank branche(per 100,000 adults) in Sub-Saharan Africa (developing only) and Bank branche(per 100,000 adults) in Brunei Darussalam?
Provide a short and direct response. -24.49. In the year 2005, what is the difference between the Bank branche(per 100,000 adults) in Sub-Saharan Africa (developing only) and Bank branche(per 100,000 adults) in Central African Republic?
Keep it short and to the point. 1.2. In the year 2005, what is the difference between the Bank branche(per 100,000 adults) of Brunei Darussalam and Bank branche(per 100,000 adults) of Central African Republic?
Your response must be concise. 25.69. In the year 2006, what is the difference between the Bank branche(per 100,000 adults) in Fragile and conflict affected situations and Bank branche(per 100,000 adults) in Sub-Saharan Africa (developing only)?
Provide a succinct answer. 0.32. In the year 2006, what is the difference between the Bank branche(per 100,000 adults) in Fragile and conflict affected situations and Bank branche(per 100,000 adults) in Brunei Darussalam?
Provide a short and direct response. -21.19. In the year 2006, what is the difference between the Bank branche(per 100,000 adults) in Fragile and conflict affected situations and Bank branche(per 100,000 adults) in Central African Republic?
Provide a short and direct response. 1.65. In the year 2006, what is the difference between the Bank branche(per 100,000 adults) of Sub-Saharan Africa (developing only) and Bank branche(per 100,000 adults) of Brunei Darussalam?
Provide a short and direct response. -21.51. In the year 2006, what is the difference between the Bank branche(per 100,000 adults) in Sub-Saharan Africa (developing only) and Bank branche(per 100,000 adults) in Central African Republic?
Keep it short and to the point. 1.33. In the year 2006, what is the difference between the Bank branche(per 100,000 adults) in Brunei Darussalam and Bank branche(per 100,000 adults) in Central African Republic?
Your answer should be very brief. 22.84. In the year 2007, what is the difference between the Bank branche(per 100,000 adults) of Fragile and conflict affected situations and Bank branche(per 100,000 adults) of Sub-Saharan Africa (developing only)?
Provide a succinct answer. 0.1. In the year 2007, what is the difference between the Bank branche(per 100,000 adults) of Fragile and conflict affected situations and Bank branche(per 100,000 adults) of Brunei Darussalam?
Make the answer very short. -20.4. In the year 2007, what is the difference between the Bank branche(per 100,000 adults) of Fragile and conflict affected situations and Bank branche(per 100,000 adults) of Central African Republic?
Your answer should be very brief. 1.68. In the year 2007, what is the difference between the Bank branche(per 100,000 adults) of Sub-Saharan Africa (developing only) and Bank branche(per 100,000 adults) of Brunei Darussalam?
Keep it short and to the point. -20.51. In the year 2007, what is the difference between the Bank branche(per 100,000 adults) of Sub-Saharan Africa (developing only) and Bank branche(per 100,000 adults) of Central African Republic?
Keep it short and to the point. 1.57. In the year 2007, what is the difference between the Bank branche(per 100,000 adults) in Brunei Darussalam and Bank branche(per 100,000 adults) in Central African Republic?
Ensure brevity in your answer.  22.08. In the year 2008, what is the difference between the Bank branche(per 100,000 adults) of Fragile and conflict affected situations and Bank branche(per 100,000 adults) of Sub-Saharan Africa (developing only)?
Make the answer very short. -0.02. In the year 2008, what is the difference between the Bank branche(per 100,000 adults) in Fragile and conflict affected situations and Bank branche(per 100,000 adults) in Brunei Darussalam?
Your response must be concise. -20.35. In the year 2008, what is the difference between the Bank branche(per 100,000 adults) of Fragile and conflict affected situations and Bank branche(per 100,000 adults) of Central African Republic?
Keep it short and to the point. 1.88. In the year 2008, what is the difference between the Bank branche(per 100,000 adults) of Sub-Saharan Africa (developing only) and Bank branche(per 100,000 adults) of Brunei Darussalam?
Offer a very short reply. -20.33. In the year 2008, what is the difference between the Bank branche(per 100,000 adults) of Sub-Saharan Africa (developing only) and Bank branche(per 100,000 adults) of Central African Republic?
Provide a succinct answer. 1.9. In the year 2008, what is the difference between the Bank branche(per 100,000 adults) of Brunei Darussalam and Bank branche(per 100,000 adults) of Central African Republic?
Ensure brevity in your answer.  22.23. In the year 2009, what is the difference between the Bank branche(per 100,000 adults) of Fragile and conflict affected situations and Bank branche(per 100,000 adults) of Brunei Darussalam?
Provide a succinct answer. -20.45. In the year 2009, what is the difference between the Bank branche(per 100,000 adults) in Fragile and conflict affected situations and Bank branche(per 100,000 adults) in Central African Republic?
Give a very brief answer. 2.08. In the year 2009, what is the difference between the Bank branche(per 100,000 adults) of Sub-Saharan Africa (developing only) and Bank branche(per 100,000 adults) of Brunei Darussalam?
Your response must be concise. -20.45. In the year 2009, what is the difference between the Bank branche(per 100,000 adults) in Sub-Saharan Africa (developing only) and Bank branche(per 100,000 adults) in Central African Republic?
Ensure brevity in your answer.  2.08. In the year 2009, what is the difference between the Bank branche(per 100,000 adults) of Brunei Darussalam and Bank branche(per 100,000 adults) of Central African Republic?
Keep it short and to the point. 22.53. In the year 2010, what is the difference between the Bank branche(per 100,000 adults) in Fragile and conflict affected situations and Bank branche(per 100,000 adults) in Sub-Saharan Africa (developing only)?
Your answer should be compact. -0.61. In the year 2010, what is the difference between the Bank branche(per 100,000 adults) of Fragile and conflict affected situations and Bank branche(per 100,000 adults) of Brunei Darussalam?
Keep it short and to the point. -19.96. In the year 2010, what is the difference between the Bank branche(per 100,000 adults) of Fragile and conflict affected situations and Bank branche(per 100,000 adults) of Central African Republic?
Provide a short and direct response. 1.97. In the year 2010, what is the difference between the Bank branche(per 100,000 adults) in Sub-Saharan Africa (developing only) and Bank branche(per 100,000 adults) in Brunei Darussalam?
Make the answer very short. -19.35. In the year 2010, what is the difference between the Bank branche(per 100,000 adults) of Sub-Saharan Africa (developing only) and Bank branche(per 100,000 adults) of Central African Republic?
Offer a terse response. 2.58. In the year 2010, what is the difference between the Bank branche(per 100,000 adults) in Brunei Darussalam and Bank branche(per 100,000 adults) in Central African Republic?
Provide a succinct answer. 21.93. In the year 2011, what is the difference between the Bank branche(per 100,000 adults) in Fragile and conflict affected situations and Bank branche(per 100,000 adults) in Sub-Saharan Africa (developing only)?
Your response must be concise. 0.18. In the year 2011, what is the difference between the Bank branche(per 100,000 adults) of Fragile and conflict affected situations and Bank branche(per 100,000 adults) of Brunei Darussalam?
Provide a short and direct response. -18.94. In the year 2011, what is the difference between the Bank branche(per 100,000 adults) in Fragile and conflict affected situations and Bank branche(per 100,000 adults) in Central African Republic?
Offer a very short reply. 2.84. In the year 2011, what is the difference between the Bank branche(per 100,000 adults) in Sub-Saharan Africa (developing only) and Bank branche(per 100,000 adults) in Brunei Darussalam?
Keep it short and to the point. -19.12. In the year 2011, what is the difference between the Bank branche(per 100,000 adults) in Sub-Saharan Africa (developing only) and Bank branche(per 100,000 adults) in Central African Republic?
Your answer should be very brief. 2.67. In the year 2011, what is the difference between the Bank branche(per 100,000 adults) in Brunei Darussalam and Bank branche(per 100,000 adults) in Central African Republic?
Give a very brief answer. 21.79. In the year 2012, what is the difference between the Bank branche(per 100,000 adults) of Fragile and conflict affected situations and Bank branche(per 100,000 adults) of Brunei Darussalam?
Offer a terse response. -18.57. In the year 2012, what is the difference between the Bank branche(per 100,000 adults) in Fragile and conflict affected situations and Bank branche(per 100,000 adults) in Central African Republic?
Make the answer very short. 2.76. In the year 2012, what is the difference between the Bank branche(per 100,000 adults) of Sub-Saharan Africa (developing only) and Bank branche(per 100,000 adults) of Brunei Darussalam?
Ensure brevity in your answer.  -18.57. In the year 2012, what is the difference between the Bank branche(per 100,000 adults) in Sub-Saharan Africa (developing only) and Bank branche(per 100,000 adults) in Central African Republic?
Your answer should be very brief. 2.76. In the year 2012, what is the difference between the Bank branche(per 100,000 adults) in Brunei Darussalam and Bank branche(per 100,000 adults) in Central African Republic?
Offer a terse response. 21.33. What is the ratio of the Bank branche(per 100,000 adults) of Fragile and conflict affected situations in 2005 to that in 2006?
Your answer should be very brief. 0.96. What is the ratio of the Bank branche(per 100,000 adults) of Sub-Saharan Africa (developing only) in 2005 to that in 2006?
Offer a terse response. 0.92. What is the ratio of the Bank branche(per 100,000 adults) in Brunei Darussalam in 2005 to that in 2006?
Ensure brevity in your answer.  1.12. What is the ratio of the Bank branche(per 100,000 adults) of Central African Republic in 2005 to that in 2006?
Give a very brief answer. 1.02. What is the ratio of the Bank branche(per 100,000 adults) of Fragile and conflict affected situations in 2005 to that in 2007?
Ensure brevity in your answer.  0.86. What is the ratio of the Bank branche(per 100,000 adults) in Sub-Saharan Africa (developing only) in 2005 to that in 2007?
Provide a succinct answer. 0.72. What is the ratio of the Bank branche(per 100,000 adults) of Brunei Darussalam in 2005 to that in 2007?
Provide a succinct answer. 1.15. What is the ratio of the Bank branche(per 100,000 adults) in Central African Republic in 2005 to that in 2007?
Give a very brief answer. 0.61. What is the ratio of the Bank branche(per 100,000 adults) in Fragile and conflict affected situations in 2005 to that in 2008?
Your answer should be very brief. 0.78. What is the ratio of the Bank branche(per 100,000 adults) in Sub-Saharan Africa (developing only) in 2005 to that in 2008?
Provide a short and direct response. 0.62. What is the ratio of the Bank branche(per 100,000 adults) of Brunei Darussalam in 2005 to that in 2008?
Make the answer very short. 1.14. What is the ratio of the Bank branche(per 100,000 adults) of Central African Republic in 2005 to that in 2008?
Make the answer very short. 0.58. What is the ratio of the Bank branche(per 100,000 adults) in Fragile and conflict affected situations in 2005 to that in 2009?
Offer a very short reply. 0.66. What is the ratio of the Bank branche(per 100,000 adults) in Sub-Saharan Africa (developing only) in 2005 to that in 2009?
Your answer should be compact. 0.53. What is the ratio of the Bank branche(per 100,000 adults) in Brunei Darussalam in 2005 to that in 2009?
Provide a short and direct response. 1.12. What is the ratio of the Bank branche(per 100,000 adults) in Central African Republic in 2005 to that in 2009?
Offer a terse response. 0.4. What is the ratio of the Bank branche(per 100,000 adults) of Fragile and conflict affected situations in 2005 to that in 2010?
Your answer should be very brief. 0.66. What is the ratio of the Bank branche(per 100,000 adults) in Sub-Saharan Africa (developing only) in 2005 to that in 2010?
Give a very brief answer. 0.44. What is the ratio of the Bank branche(per 100,000 adults) in Brunei Darussalam in 2005 to that in 2010?
Offer a terse response. 1.14. What is the ratio of the Bank branche(per 100,000 adults) of Central African Republic in 2005 to that in 2010?
Give a very brief answer. 0.36. What is the ratio of the Bank branche(per 100,000 adults) in Fragile and conflict affected situations in 2005 to that in 2011?
Your response must be concise. 0.5. What is the ratio of the Bank branche(per 100,000 adults) of Sub-Saharan Africa (developing only) in 2005 to that in 2011?
Give a very brief answer. 0.42. What is the ratio of the Bank branche(per 100,000 adults) of Brunei Darussalam in 2005 to that in 2011?
Offer a very short reply. 1.15. What is the ratio of the Bank branche(per 100,000 adults) of Central African Republic in 2005 to that in 2011?
Make the answer very short. 0.35. What is the ratio of the Bank branche(per 100,000 adults) in Fragile and conflict affected situations in 2005 to that in 2012?
Provide a succinct answer. 0.51. What is the ratio of the Bank branche(per 100,000 adults) in Sub-Saharan Africa (developing only) in 2005 to that in 2012?
Your answer should be compact. 0.41. What is the ratio of the Bank branche(per 100,000 adults) in Brunei Darussalam in 2005 to that in 2012?
Your answer should be compact. 1.17. What is the ratio of the Bank branche(per 100,000 adults) in Central African Republic in 2005 to that in 2012?
Ensure brevity in your answer.  0.34. What is the ratio of the Bank branche(per 100,000 adults) of Fragile and conflict affected situations in 2006 to that in 2007?
Provide a short and direct response. 0.89. What is the ratio of the Bank branche(per 100,000 adults) in Sub-Saharan Africa (developing only) in 2006 to that in 2007?
Provide a short and direct response. 0.78. What is the ratio of the Bank branche(per 100,000 adults) in Brunei Darussalam in 2006 to that in 2007?
Provide a short and direct response. 1.02. What is the ratio of the Bank branche(per 100,000 adults) of Central African Republic in 2006 to that in 2007?
Give a very brief answer. 0.6. What is the ratio of the Bank branche(per 100,000 adults) in Fragile and conflict affected situations in 2006 to that in 2008?
Offer a terse response. 0.81. What is the ratio of the Bank branche(per 100,000 adults) in Sub-Saharan Africa (developing only) in 2006 to that in 2008?
Offer a terse response. 0.67. What is the ratio of the Bank branche(per 100,000 adults) in Brunei Darussalam in 2006 to that in 2008?
Ensure brevity in your answer.  1.02. What is the ratio of the Bank branche(per 100,000 adults) in Central African Republic in 2006 to that in 2008?
Give a very brief answer. 0.56. What is the ratio of the Bank branche(per 100,000 adults) of Fragile and conflict affected situations in 2006 to that in 2009?
Keep it short and to the point. 0.69. What is the ratio of the Bank branche(per 100,000 adults) of Sub-Saharan Africa (developing only) in 2006 to that in 2009?
Provide a succinct answer. 0.57. What is the ratio of the Bank branche(per 100,000 adults) in Brunei Darussalam in 2006 to that in 2009?
Offer a very short reply. 0.99. What is the ratio of the Bank branche(per 100,000 adults) in Central African Republic in 2006 to that in 2009?
Provide a short and direct response. 0.39. What is the ratio of the Bank branche(per 100,000 adults) of Fragile and conflict affected situations in 2006 to that in 2010?
Give a very brief answer. 0.69. What is the ratio of the Bank branche(per 100,000 adults) of Sub-Saharan Africa (developing only) in 2006 to that in 2010?
Offer a very short reply. 0.47. What is the ratio of the Bank branche(per 100,000 adults) of Brunei Darussalam in 2006 to that in 2010?
Offer a very short reply. 1.02. What is the ratio of the Bank branche(per 100,000 adults) of Central African Republic in 2006 to that in 2010?
Provide a succinct answer. 0.35. What is the ratio of the Bank branche(per 100,000 adults) of Fragile and conflict affected situations in 2006 to that in 2011?
Make the answer very short. 0.52. What is the ratio of the Bank branche(per 100,000 adults) of Sub-Saharan Africa (developing only) in 2006 to that in 2011?
Keep it short and to the point. 0.46. What is the ratio of the Bank branche(per 100,000 adults) of Brunei Darussalam in 2006 to that in 2011?
Your answer should be very brief. 1.02. What is the ratio of the Bank branche(per 100,000 adults) in Central African Republic in 2006 to that in 2011?
Your response must be concise. 0.34. What is the ratio of the Bank branche(per 100,000 adults) in Fragile and conflict affected situations in 2006 to that in 2012?
Offer a very short reply. 0.53. What is the ratio of the Bank branche(per 100,000 adults) of Sub-Saharan Africa (developing only) in 2006 to that in 2012?
Ensure brevity in your answer.  0.45. What is the ratio of the Bank branche(per 100,000 adults) in Brunei Darussalam in 2006 to that in 2012?
Keep it short and to the point. 1.04. What is the ratio of the Bank branche(per 100,000 adults) in Central African Republic in 2006 to that in 2012?
Make the answer very short. 0.34. What is the ratio of the Bank branche(per 100,000 adults) in Fragile and conflict affected situations in 2007 to that in 2008?
Offer a very short reply. 0.9. What is the ratio of the Bank branche(per 100,000 adults) in Sub-Saharan Africa (developing only) in 2007 to that in 2008?
Ensure brevity in your answer.  0.85. What is the ratio of the Bank branche(per 100,000 adults) in Central African Republic in 2007 to that in 2008?
Offer a terse response. 0.94. What is the ratio of the Bank branche(per 100,000 adults) in Fragile and conflict affected situations in 2007 to that in 2009?
Your answer should be very brief. 0.77. What is the ratio of the Bank branche(per 100,000 adults) of Sub-Saharan Africa (developing only) in 2007 to that in 2009?
Offer a terse response. 0.73. What is the ratio of the Bank branche(per 100,000 adults) in Brunei Darussalam in 2007 to that in 2009?
Keep it short and to the point. 0.97. What is the ratio of the Bank branche(per 100,000 adults) of Central African Republic in 2007 to that in 2009?
Offer a terse response. 0.66. What is the ratio of the Bank branche(per 100,000 adults) in Fragile and conflict affected situations in 2007 to that in 2010?
Provide a short and direct response. 0.77. What is the ratio of the Bank branche(per 100,000 adults) of Sub-Saharan Africa (developing only) in 2007 to that in 2010?
Offer a terse response. 0.6. What is the ratio of the Bank branche(per 100,000 adults) of Brunei Darussalam in 2007 to that in 2010?
Your response must be concise. 0.99. What is the ratio of the Bank branche(per 100,000 adults) in Central African Republic in 2007 to that in 2010?
Offer a very short reply. 0.59. What is the ratio of the Bank branche(per 100,000 adults) of Fragile and conflict affected situations in 2007 to that in 2011?
Provide a succinct answer. 0.59. What is the ratio of the Bank branche(per 100,000 adults) of Sub-Saharan Africa (developing only) in 2007 to that in 2011?
Give a very brief answer. 0.59. What is the ratio of the Bank branche(per 100,000 adults) of Brunei Darussalam in 2007 to that in 2011?
Give a very brief answer. 1. What is the ratio of the Bank branche(per 100,000 adults) of Central African Republic in 2007 to that in 2011?
Make the answer very short. 0.57. What is the ratio of the Bank branche(per 100,000 adults) in Fragile and conflict affected situations in 2007 to that in 2012?
Provide a short and direct response. 0.6. What is the ratio of the Bank branche(per 100,000 adults) of Sub-Saharan Africa (developing only) in 2007 to that in 2012?
Your answer should be compact. 0.57. What is the ratio of the Bank branche(per 100,000 adults) of Brunei Darussalam in 2007 to that in 2012?
Give a very brief answer. 1.02. What is the ratio of the Bank branche(per 100,000 adults) in Central African Republic in 2007 to that in 2012?
Provide a succinct answer. 0.56. What is the ratio of the Bank branche(per 100,000 adults) in Fragile and conflict affected situations in 2008 to that in 2009?
Offer a very short reply. 0.85. What is the ratio of the Bank branche(per 100,000 adults) in Sub-Saharan Africa (developing only) in 2008 to that in 2009?
Keep it short and to the point. 0.86. What is the ratio of the Bank branche(per 100,000 adults) in Brunei Darussalam in 2008 to that in 2009?
Provide a short and direct response. 0.98. What is the ratio of the Bank branche(per 100,000 adults) in Central African Republic in 2008 to that in 2009?
Provide a succinct answer. 0.7. What is the ratio of the Bank branche(per 100,000 adults) of Fragile and conflict affected situations in 2008 to that in 2010?
Your answer should be compact. 0.85. What is the ratio of the Bank branche(per 100,000 adults) in Sub-Saharan Africa (developing only) in 2008 to that in 2010?
Your response must be concise. 0.71. What is the ratio of the Bank branche(per 100,000 adults) of Central African Republic in 2008 to that in 2010?
Provide a succinct answer. 0.62. What is the ratio of the Bank branche(per 100,000 adults) in Fragile and conflict affected situations in 2008 to that in 2011?
Provide a short and direct response. 0.65. What is the ratio of the Bank branche(per 100,000 adults) of Sub-Saharan Africa (developing only) in 2008 to that in 2011?
Your response must be concise. 0.69. What is the ratio of the Bank branche(per 100,000 adults) in Central African Republic in 2008 to that in 2011?
Offer a terse response. 0.61. What is the ratio of the Bank branche(per 100,000 adults) in Fragile and conflict affected situations in 2008 to that in 2012?
Provide a succinct answer. 0.66. What is the ratio of the Bank branche(per 100,000 adults) of Sub-Saharan Africa (developing only) in 2008 to that in 2012?
Offer a terse response. 0.67. What is the ratio of the Bank branche(per 100,000 adults) in Brunei Darussalam in 2008 to that in 2012?
Your answer should be very brief. 1.02. What is the ratio of the Bank branche(per 100,000 adults) of Central African Republic in 2008 to that in 2012?
Your response must be concise. 0.6. What is the ratio of the Bank branche(per 100,000 adults) of Sub-Saharan Africa (developing only) in 2009 to that in 2010?
Ensure brevity in your answer.  0.83. What is the ratio of the Bank branche(per 100,000 adults) of Brunei Darussalam in 2009 to that in 2010?
Keep it short and to the point. 1.02. What is the ratio of the Bank branche(per 100,000 adults) of Central African Republic in 2009 to that in 2010?
Your response must be concise. 0.88. What is the ratio of the Bank branche(per 100,000 adults) of Fragile and conflict affected situations in 2009 to that in 2011?
Your answer should be very brief. 0.76. What is the ratio of the Bank branche(per 100,000 adults) in Sub-Saharan Africa (developing only) in 2009 to that in 2011?
Ensure brevity in your answer.  0.8. What is the ratio of the Bank branche(per 100,000 adults) of Brunei Darussalam in 2009 to that in 2011?
Make the answer very short. 1.03. What is the ratio of the Bank branche(per 100,000 adults) in Central African Republic in 2009 to that in 2011?
Ensure brevity in your answer.  0.87. What is the ratio of the Bank branche(per 100,000 adults) of Fragile and conflict affected situations in 2009 to that in 2012?
Your response must be concise. 0.78. What is the ratio of the Bank branche(per 100,000 adults) of Sub-Saharan Africa (developing only) in 2009 to that in 2012?
Your response must be concise. 0.78. What is the ratio of the Bank branche(per 100,000 adults) of Brunei Darussalam in 2009 to that in 2012?
Make the answer very short. 1.05. What is the ratio of the Bank branche(per 100,000 adults) in Central African Republic in 2009 to that in 2012?
Offer a terse response. 0.85. What is the ratio of the Bank branche(per 100,000 adults) in Fragile and conflict affected situations in 2010 to that in 2011?
Keep it short and to the point. 0.76. What is the ratio of the Bank branche(per 100,000 adults) in Sub-Saharan Africa (developing only) in 2010 to that in 2011?
Keep it short and to the point. 0.97. What is the ratio of the Bank branche(per 100,000 adults) of Brunei Darussalam in 2010 to that in 2011?
Your response must be concise. 1.01. What is the ratio of the Bank branche(per 100,000 adults) in Central African Republic in 2010 to that in 2011?
Provide a succinct answer. 0.98. What is the ratio of the Bank branche(per 100,000 adults) of Fragile and conflict affected situations in 2010 to that in 2012?
Provide a short and direct response. 0.77. What is the ratio of the Bank branche(per 100,000 adults) of Sub-Saharan Africa (developing only) in 2010 to that in 2012?
Ensure brevity in your answer.  0.94. What is the ratio of the Bank branche(per 100,000 adults) of Brunei Darussalam in 2010 to that in 2012?
Ensure brevity in your answer.  1.03. What is the ratio of the Bank branche(per 100,000 adults) in Central African Republic in 2010 to that in 2012?
Give a very brief answer. 0.96. What is the ratio of the Bank branche(per 100,000 adults) in Fragile and conflict affected situations in 2011 to that in 2012?
Offer a very short reply. 1.02. What is the ratio of the Bank branche(per 100,000 adults) of Sub-Saharan Africa (developing only) in 2011 to that in 2012?
Keep it short and to the point. 0.97. What is the ratio of the Bank branche(per 100,000 adults) of Brunei Darussalam in 2011 to that in 2012?
Offer a very short reply. 1.02. What is the ratio of the Bank branche(per 100,000 adults) of Central African Republic in 2011 to that in 2012?
Your response must be concise. 0.98. What is the difference between the highest and the second highest Bank branche(per 100,000 adults) in Fragile and conflict affected situations?
Provide a succinct answer. 0.07. What is the difference between the highest and the second highest Bank branche(per 100,000 adults) of Sub-Saharan Africa (developing only)?
Offer a very short reply. 0.11. What is the difference between the highest and the second highest Bank branche(per 100,000 adults) of Brunei Darussalam?
Offer a very short reply. 2.71. What is the difference between the highest and the second highest Bank branche(per 100,000 adults) of Central African Republic?
Ensure brevity in your answer.  0.02. What is the difference between the highest and the lowest Bank branche(per 100,000 adults) in Fragile and conflict affected situations?
Your answer should be compact. 1.84. What is the difference between the highest and the lowest Bank branche(per 100,000 adults) in Sub-Saharan Africa (developing only)?
Your answer should be very brief. 2.14. What is the difference between the highest and the lowest Bank branche(per 100,000 adults) of Brunei Darussalam?
Give a very brief answer. 3.78. What is the difference between the highest and the lowest Bank branche(per 100,000 adults) of Central African Republic?
Make the answer very short. 0.59. 